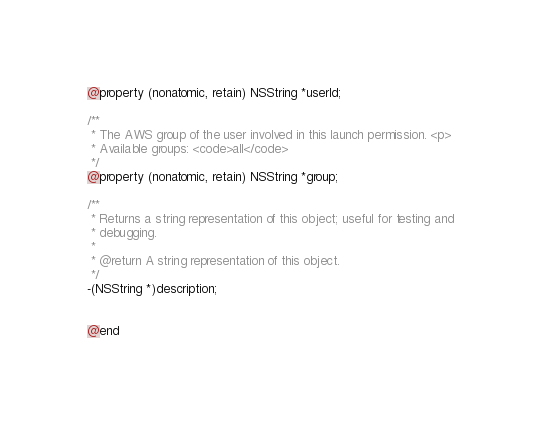Convert code to text. <code><loc_0><loc_0><loc_500><loc_500><_C_>@property (nonatomic, retain) NSString *userId;

/**
 * The AWS group of the user involved in this launch permission. <p>
 * Available groups: <code>all</code>
 */
@property (nonatomic, retain) NSString *group;

/**
 * Returns a string representation of this object; useful for testing and
 * debugging.
 *
 * @return A string representation of this object.
 */
-(NSString *)description;


@end
</code> 